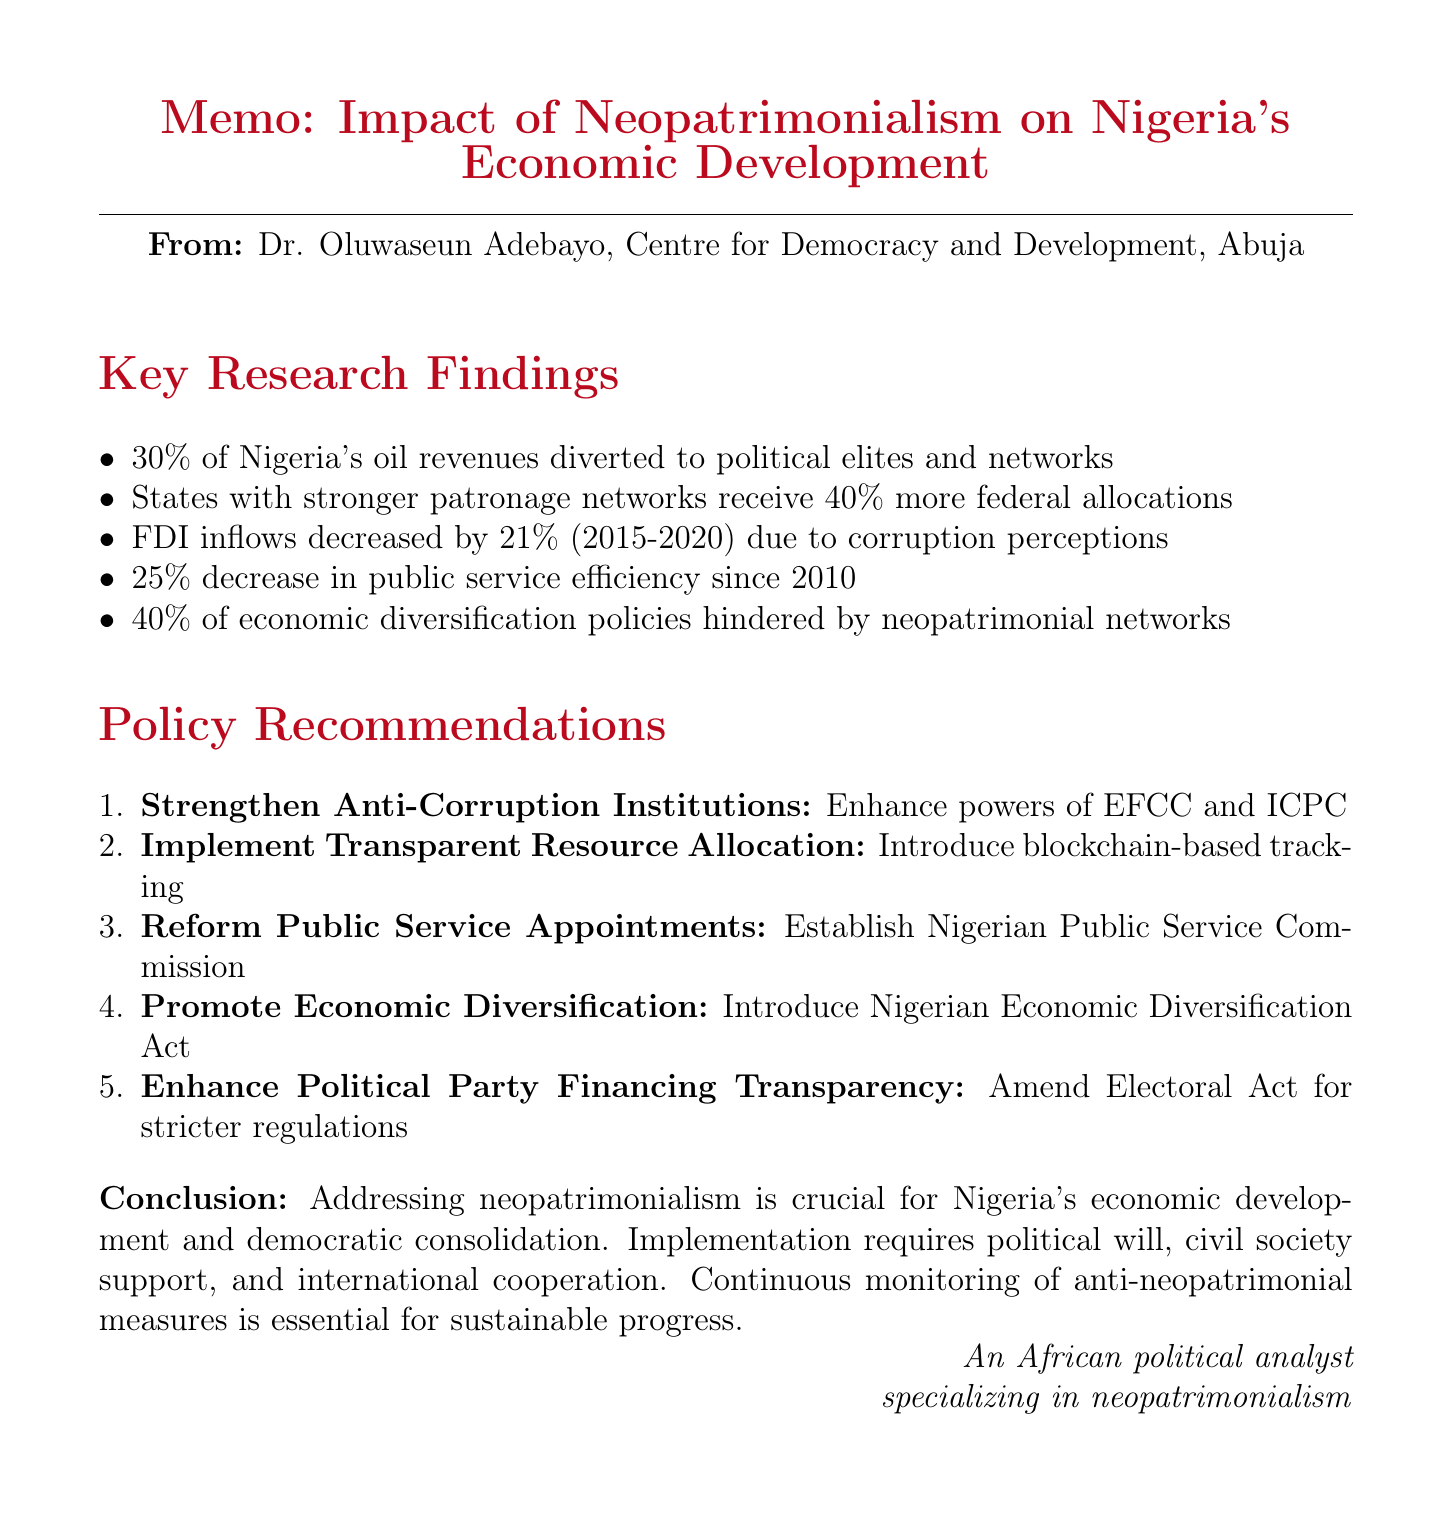What is the title of the document? The title is clearly mentioned at the beginning of the memo.
Answer: Impact of Neopatrimonialism on Economic Development in Nigeria: Research Findings and Policy Recommendations Who is the author of the memo? The author is listed right under the title and organization section.
Answer: Dr. Oluwaseun Adebayo What percentage of Nigeria's oil revenues is diverted to political elites? This specific figure is presented in the findings section regarding political patronage and resource allocation.
Answer: 30% What is Nigeria's rank in the 2020 Corruption Perceptions Index? The ranking is explicitly stated in the section on corruption and foreign direct investment.
Answer: 149 out of 180 By how much did federal allocations increase for states with stronger patronage networks? This figure is provided in the findings regarding political patronage and resource allocation.
Answer: 40% What percentage of economic diversification policies has been hindered by neopatrimonial networks since 2015? This statistic is found in the economic diversification efforts section of the research findings.
Answer: 40% What is one key policy recommendation regarding anti-corruption? The document lists the recommendations, including this specific area.
Answer: Strengthen Anti-Corruption Institutions What is one action proposed for promoting economic diversification? This action is specified in the policy recommendations section under promoting economic diversification.
Answer: Introduce Nigerian Economic Diversification Act Why is addressing neopatrimonialism important for Nigeria's economy? The conclusion highlights the significance of addressing this issue.
Answer: It is crucial for Nigeria's long-term economic development and democratic consolidation 